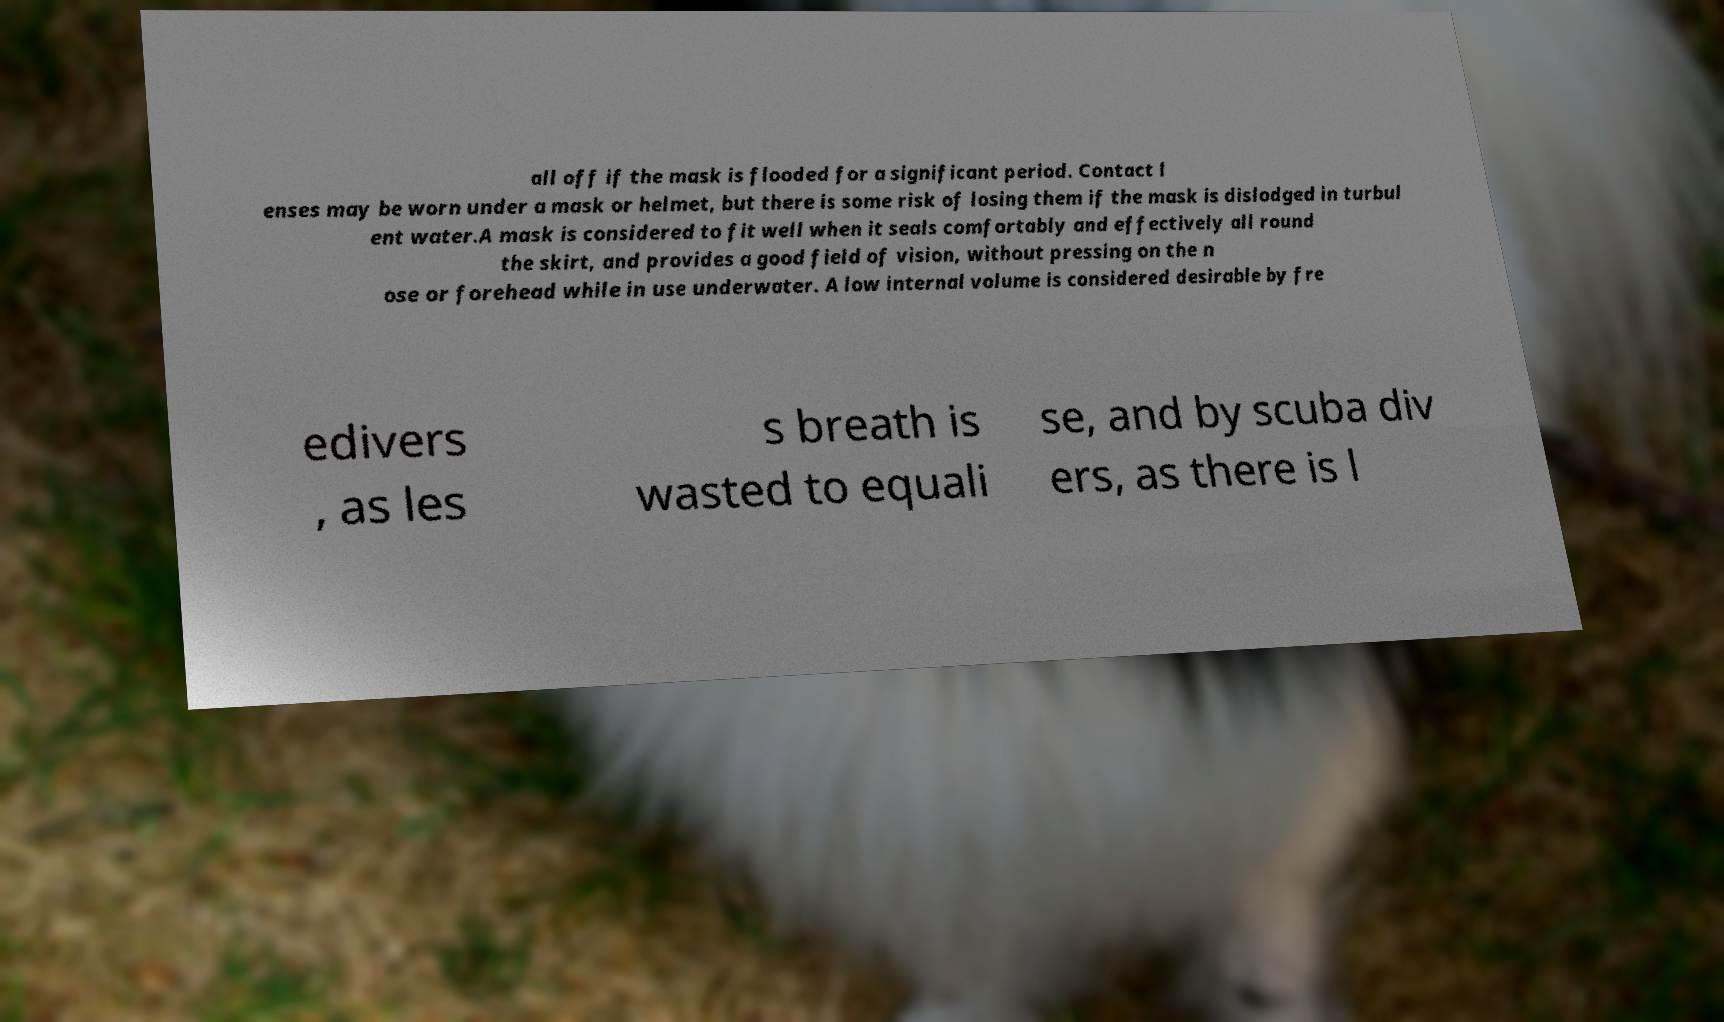Can you accurately transcribe the text from the provided image for me? all off if the mask is flooded for a significant period. Contact l enses may be worn under a mask or helmet, but there is some risk of losing them if the mask is dislodged in turbul ent water.A mask is considered to fit well when it seals comfortably and effectively all round the skirt, and provides a good field of vision, without pressing on the n ose or forehead while in use underwater. A low internal volume is considered desirable by fre edivers , as les s breath is wasted to equali se, and by scuba div ers, as there is l 